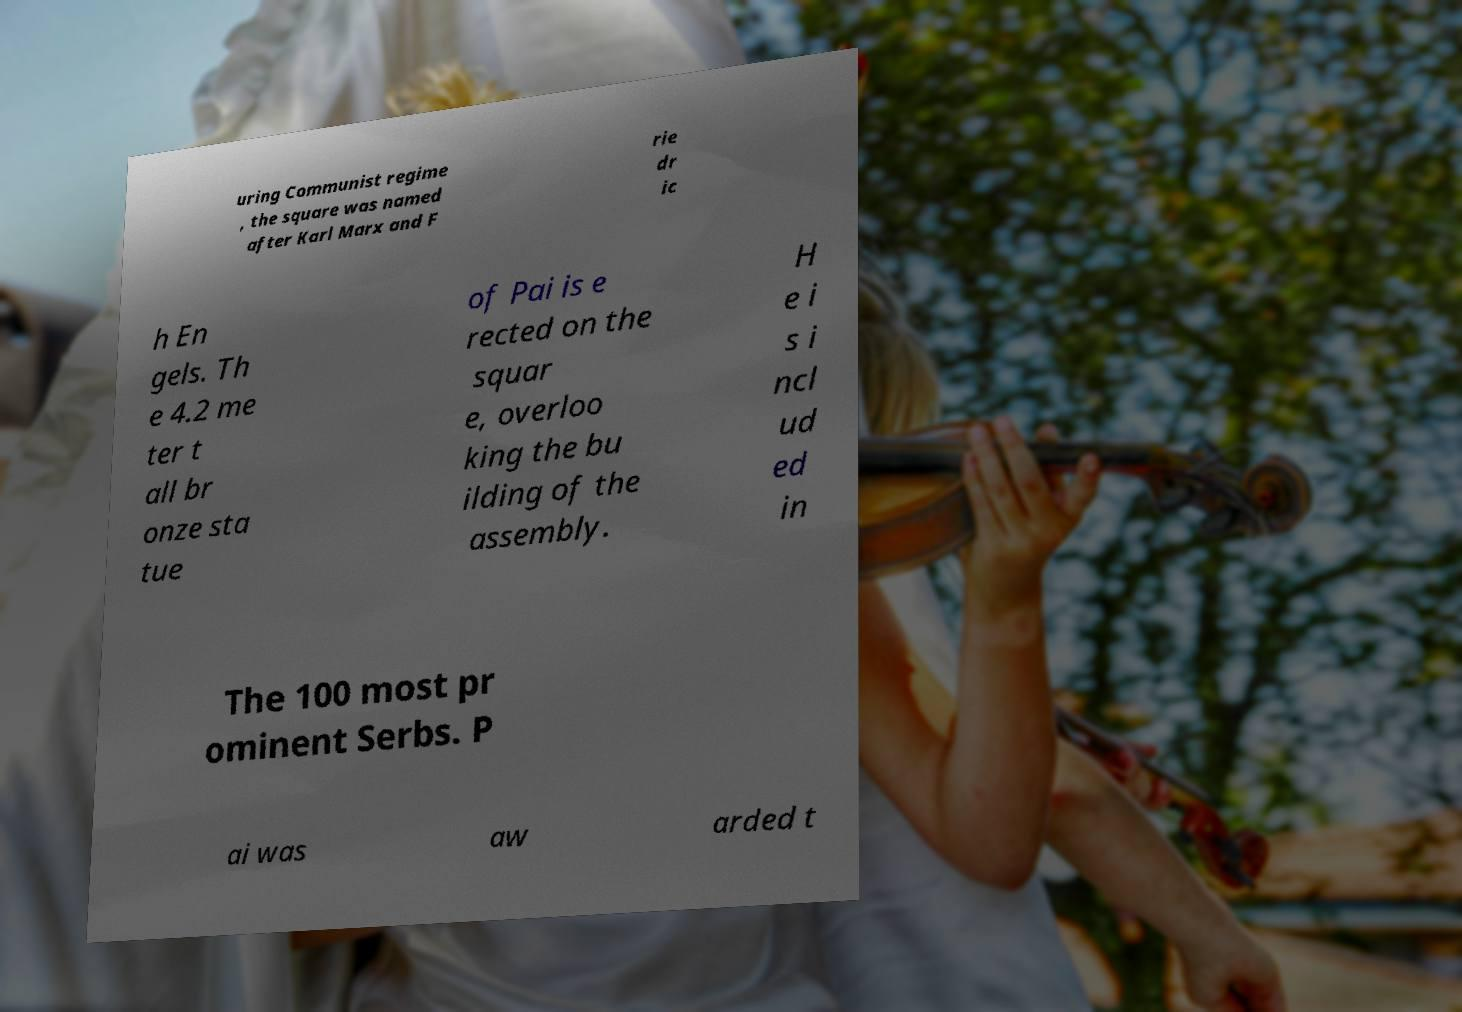For documentation purposes, I need the text within this image transcribed. Could you provide that? uring Communist regime , the square was named after Karl Marx and F rie dr ic h En gels. Th e 4.2 me ter t all br onze sta tue of Pai is e rected on the squar e, overloo king the bu ilding of the assembly. H e i s i ncl ud ed in The 100 most pr ominent Serbs. P ai was aw arded t 